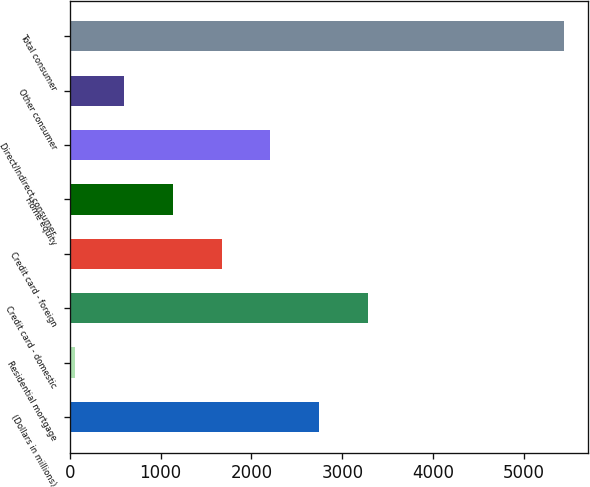<chart> <loc_0><loc_0><loc_500><loc_500><bar_chart><fcel>(Dollars in millions)<fcel>Residential mortgage<fcel>Credit card - domestic<fcel>Credit card - foreign<fcel>Home equity<fcel>Direct/Indirect consumer<fcel>Other consumer<fcel>Total consumer<nl><fcel>2747<fcel>59<fcel>3284.6<fcel>1671.8<fcel>1134.2<fcel>2209.4<fcel>596.6<fcel>5435<nl></chart> 